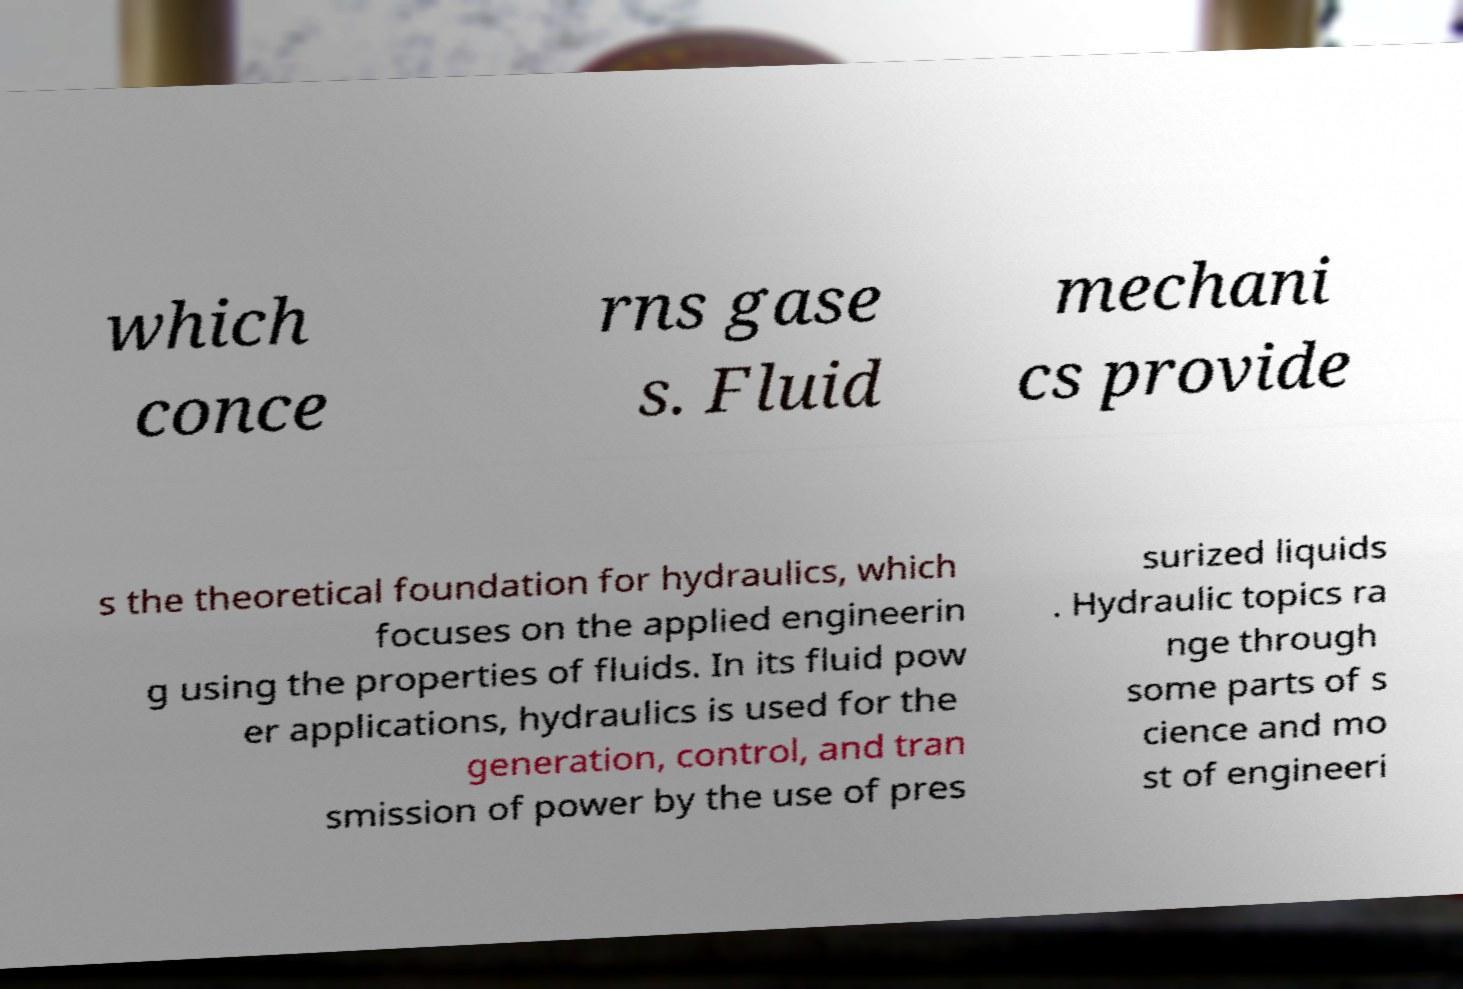For documentation purposes, I need the text within this image transcribed. Could you provide that? which conce rns gase s. Fluid mechani cs provide s the theoretical foundation for hydraulics, which focuses on the applied engineerin g using the properties of fluids. In its fluid pow er applications, hydraulics is used for the generation, control, and tran smission of power by the use of pres surized liquids . Hydraulic topics ra nge through some parts of s cience and mo st of engineeri 